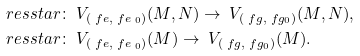Convert formula to latex. <formula><loc_0><loc_0><loc_500><loc_500>\ r e s s t a r & \colon \ V _ { ( \ f e , \ f e _ { \ 0 } ) } ( M , N ) \to \ V _ { ( \ f g , \ f g _ { 0 } ) } ( M , N ) , \\ \ r e s s t a r & \colon \ V _ { ( \ f e , \ f e _ { \ 0 } ) } ( M ) \to \ V _ { ( \ f g , \ f g _ { 0 } ) } ( M ) .</formula> 